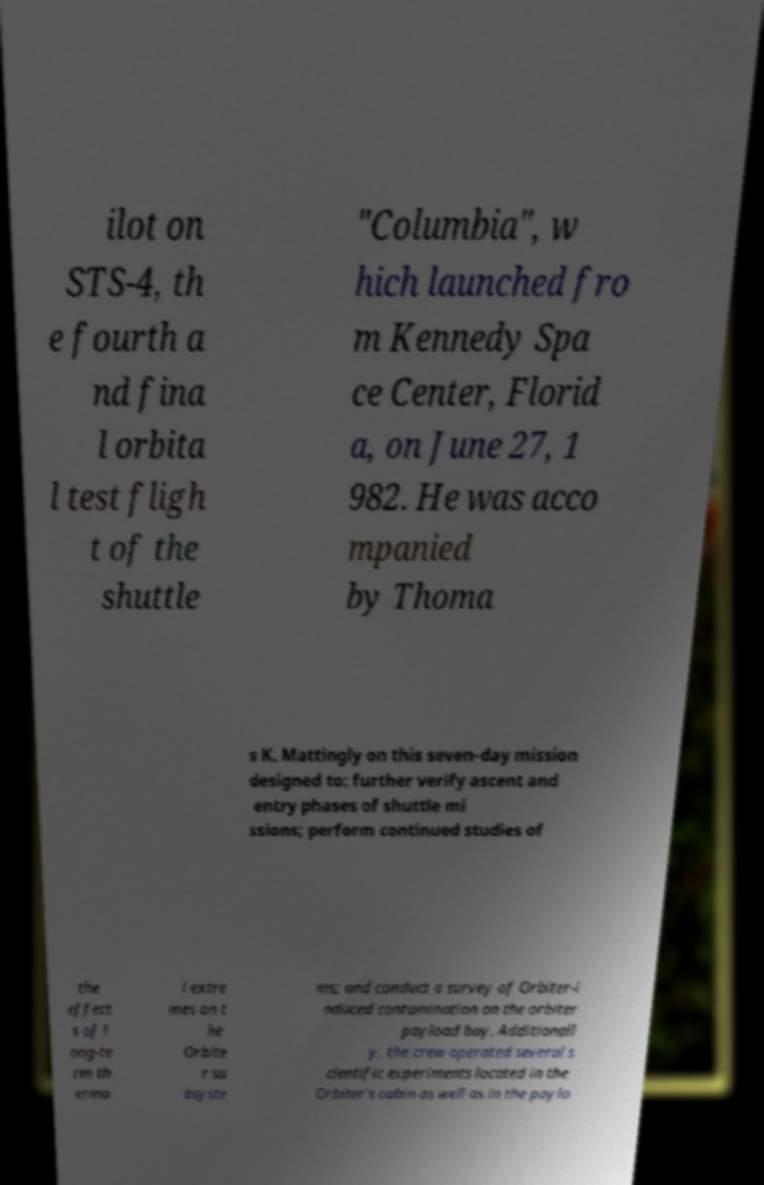There's text embedded in this image that I need extracted. Can you transcribe it verbatim? ilot on STS-4, th e fourth a nd fina l orbita l test fligh t of the shuttle "Columbia", w hich launched fro m Kennedy Spa ce Center, Florid a, on June 27, 1 982. He was acco mpanied by Thoma s K. Mattingly on this seven-day mission designed to: further verify ascent and entry phases of shuttle mi ssions; perform continued studies of the effect s of l ong-te rm th erma l extre mes on t he Orbite r su bsyste ms; and conduct a survey of Orbiter-i nduced contamination on the orbiter payload bay. Additionall y, the crew operated several s cientific experiments located in the Orbiter's cabin as well as in the paylo 